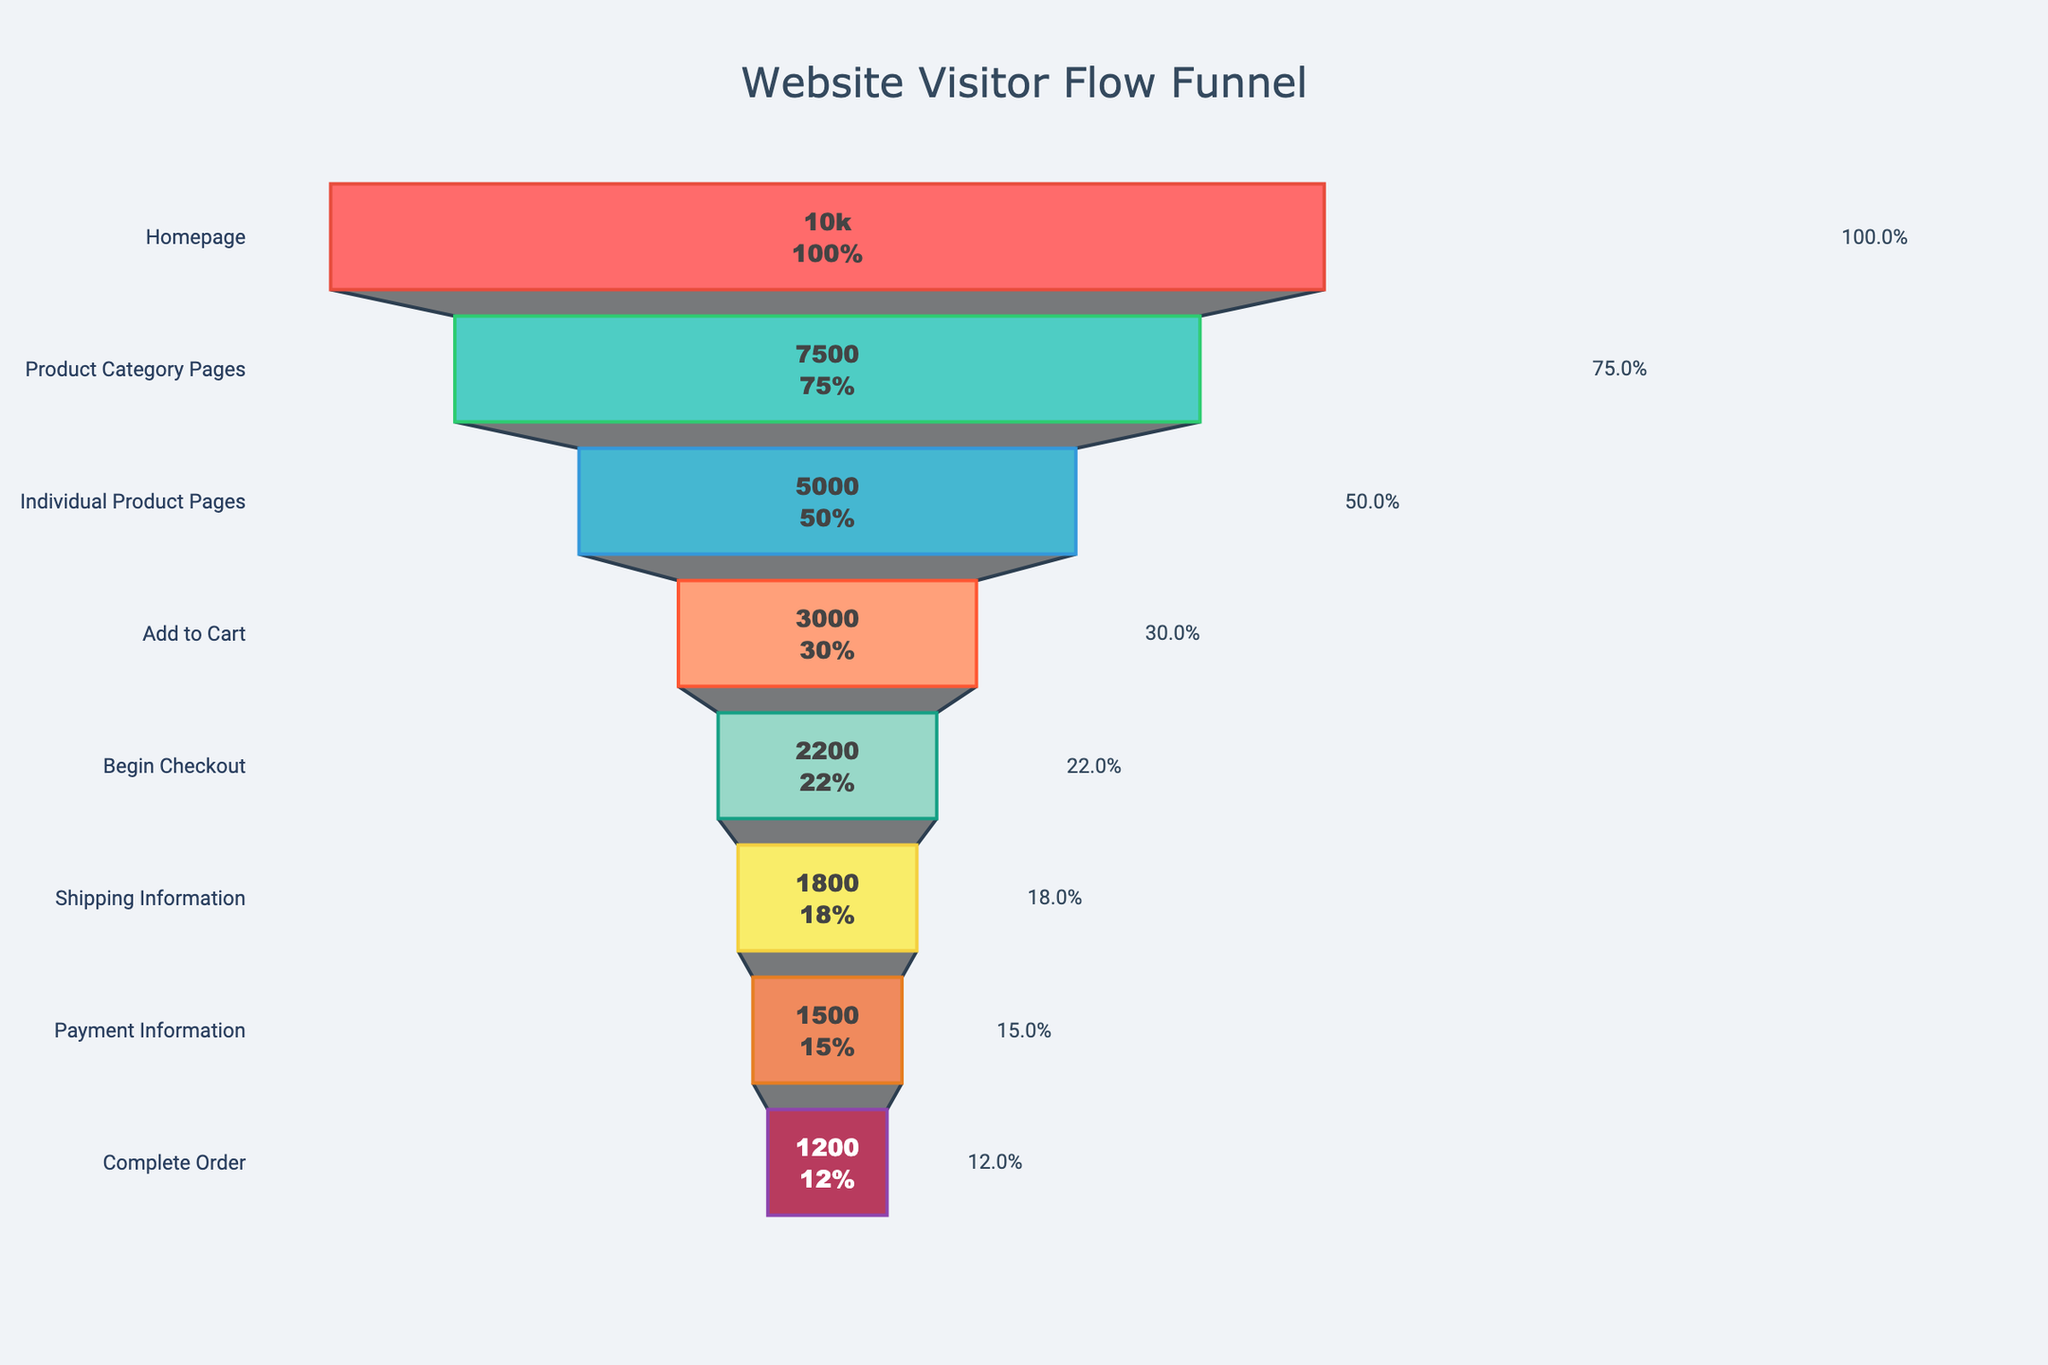what is the title of the chart? The title is positioned at the top center of the chart. It reads "Website Visitor Flow Funnel".
Answer: Website Visitor Flow Funnel What percentage of visitors move from the Homepage to the Product Category Pages? According to the funnel chart, the percentage of visitors who move from the Homepage to the Product Category Pages is given directly.
Answer: 75% What is the total number of visitors who dropped off between Individual Product Pages and Add to Cart? To find the drop-off, subtract the number of visitors at Add to Cart from those at Individual Product Pages: 5000 - 3000.
Answer: 2000 Which step has the highest drop-off rate? The drop-off rate is highest where the percentage difference between consecutive steps is greatest. Compare differences between each step to find the maximum.
Answer: Individual Product Pages to Add to Cart What proportion of visitors who added something to their cart eventually completed their order? To find this, divide the number of visitors who completed the order by those who added items to their cart: 1200/3000, then convert to percentage.
Answer: 40% How many visitors proceeded from Shipping Information to Payment Information? Compare visitor numbers at these two steps. The number at Payment Information is 1500, which indicates 1500 visitors moved from Shipping Information to Payment Information.
Answer: 1500 From which step to which step does the most significant percentage drop occur? Review the percentages between each step and identify where the largest drop in percentage occurs. From Individual Product Pages (50%) to Add to Cart (30%) has a 20% drop.
Answer: Individual Product Pages to Add to Cart Between which steps do we lose the smallest number of visitors? Check the visitor numbers for each transition, the smallest difference in visitors is between Begin Checkout and Shipping Information: 2200 - 1800 = 400.
Answer: Begin Checkout to Shipping Information What is the percentage of visitors who begin checkout but do not complete the order? Subtract the percentage of visitors who complete the order from those who begin checkout, then multiply by 100: (22% - 12%).
Answer: 10% If the conversion rate from Begin Checkout to Complete Order were improved by 5%, how many more orders would be completed? Calculate 5% of visitors who begin checkout (2200 * 0.05) and add to current completed orders: 2200 * 0.05 = 110, then 110 + 1200.
Answer: 1310 